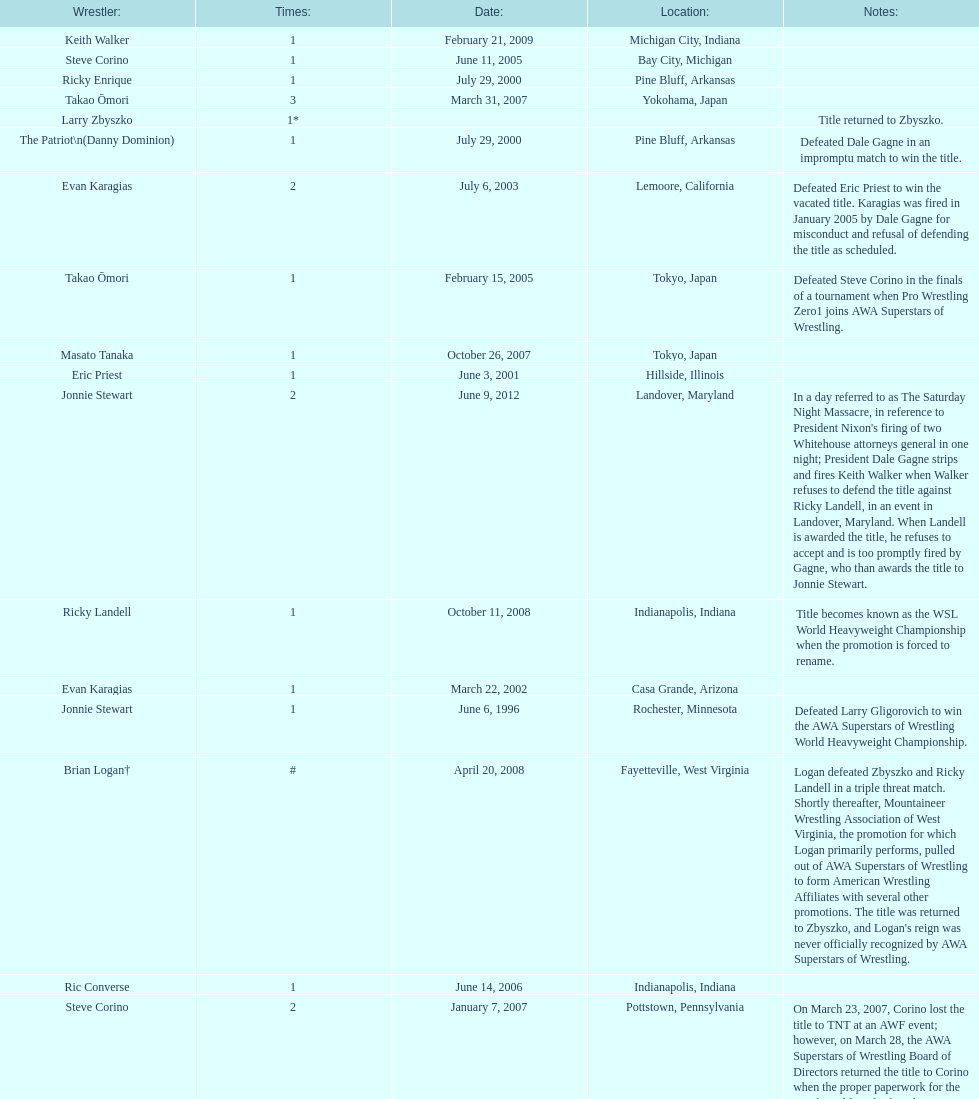Who is listed before keith walker? Ricky Landell. 